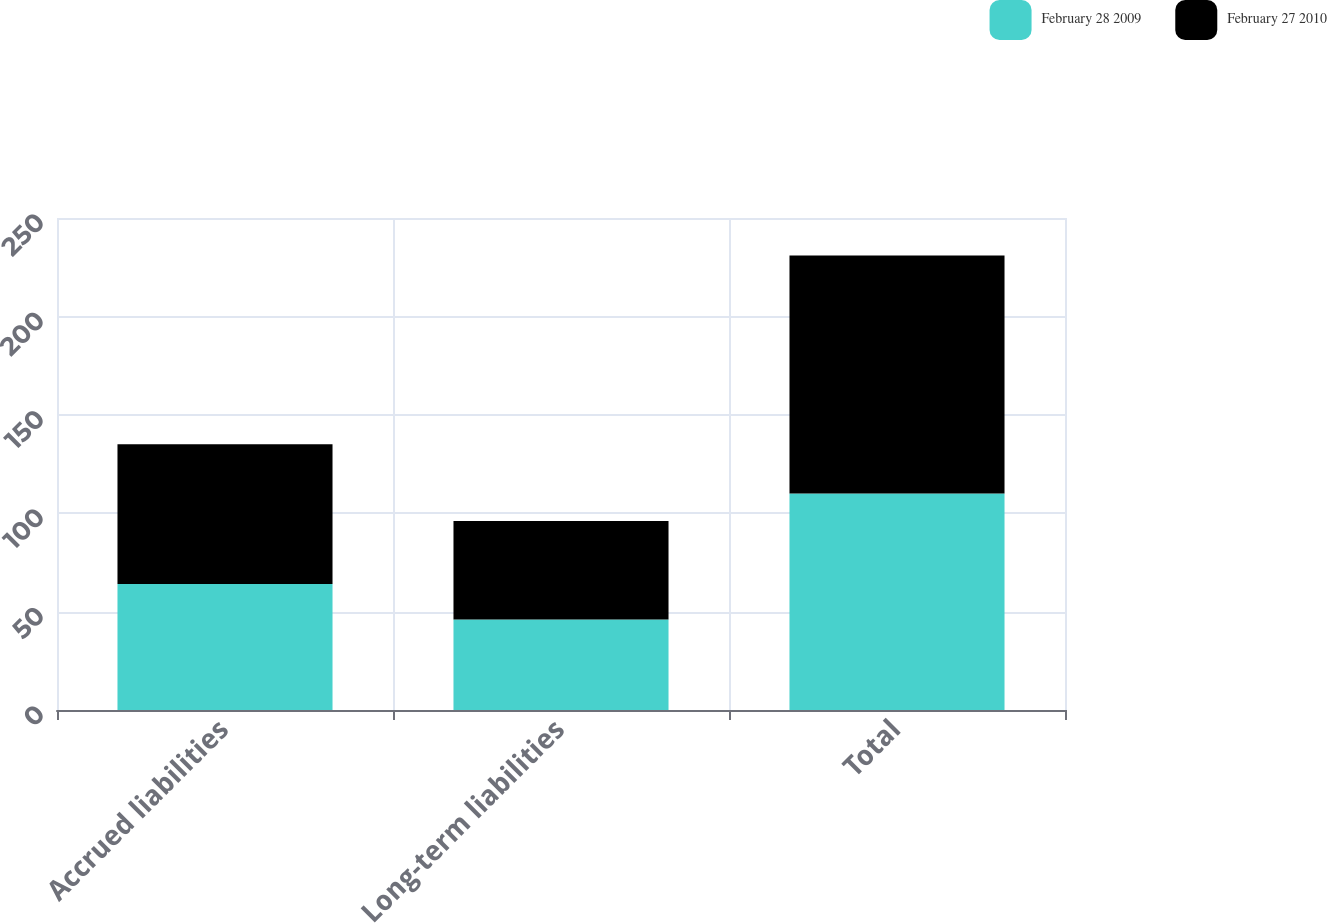Convert chart to OTSL. <chart><loc_0><loc_0><loc_500><loc_500><stacked_bar_chart><ecel><fcel>Accrued liabilities<fcel>Long-term liabilities<fcel>Total<nl><fcel>February 28 2009<fcel>64<fcel>46<fcel>110<nl><fcel>February 27 2010<fcel>71<fcel>50<fcel>121<nl></chart> 